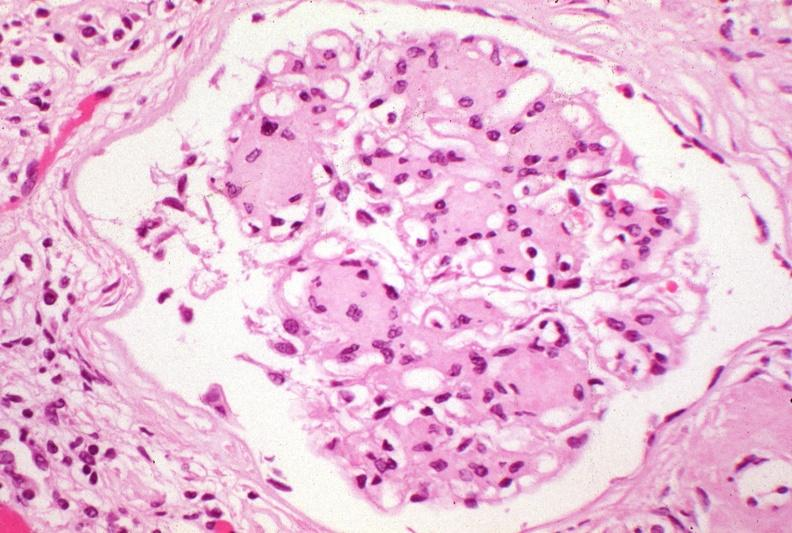where is this?
Answer the question using a single word or phrase. Urinary 